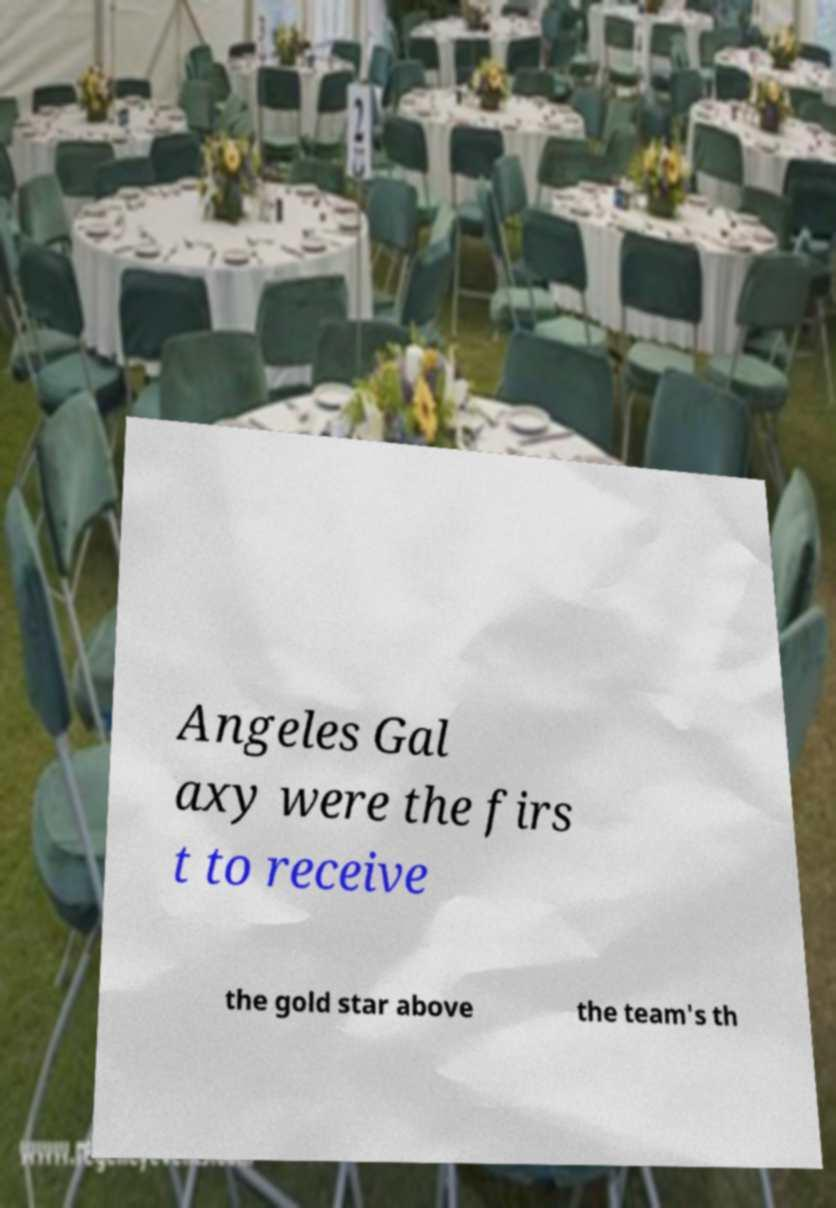There's text embedded in this image that I need extracted. Can you transcribe it verbatim? Angeles Gal axy were the firs t to receive the gold star above the team's th 